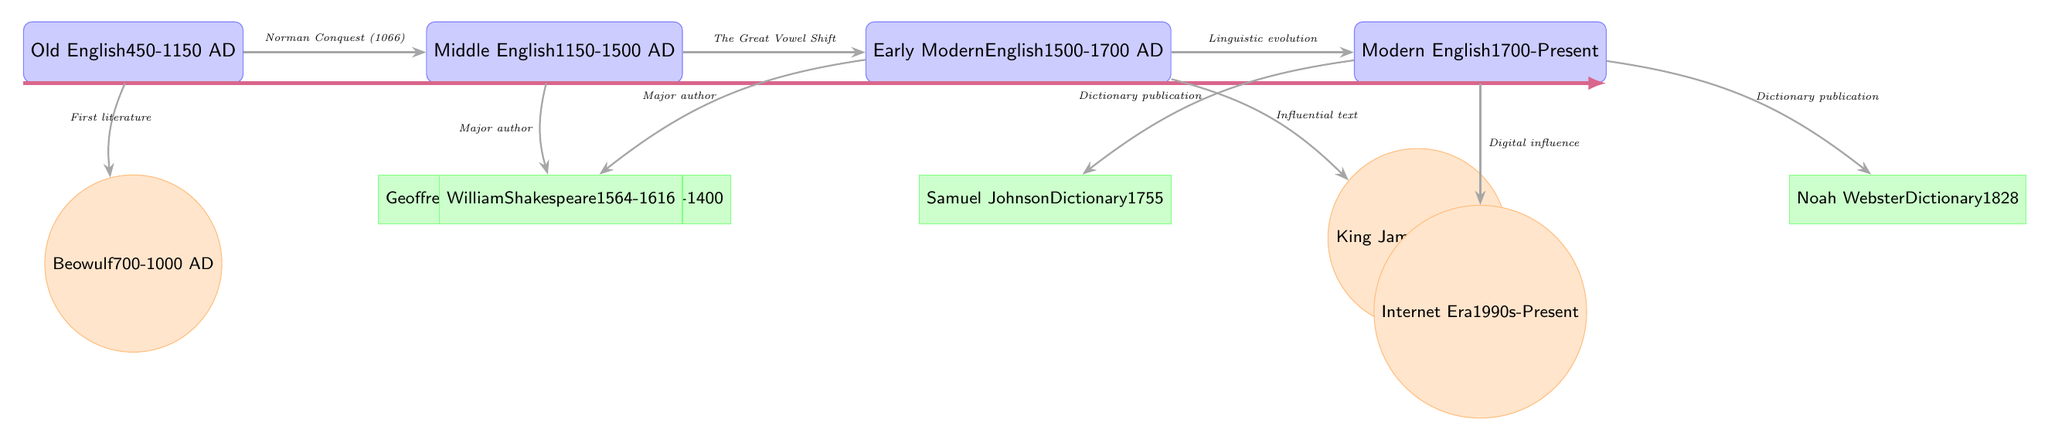What is the time period for Old English? The node labeled "Old English" states that it spans from 450 to 1150 AD. Therefore, this period can be identified directly from the diagram.
Answer: 450-1150 AD Who is the major author associated with Middle English? The diagram shows the author Geoffrey Chaucer under Middle English, and he is connected to the Canterbury Tales. This directly indicates his significance during this period.
Answer: Geoffrey Chaucer What major event led to the transition from Old English to Middle English? The diagram connects the Old English era to Middle English via the Norman Conquest (1066), marking a significant change between these periods.
Answer: Norman Conquest (1066) Which influential text was published during the Early Modern English period? Looking at the Early Modern English section, it is indicated that the King James Bible was published in 1611, making it an influential text of that time.
Answer: King James Bible How many major authors are listed in the Modern English section? The Modern English section contains two major authors, Samuel Johnson and Noah Webster, as indicated by the respective author nodes in that part of the diagram.
Answer: 2 What linguistic shift is noted between Middle English and Early Modern English? The diagram points out the Great Vowel Shift as a major linguistic change that occurred during the transition from Middle English to Early Modern English.
Answer: The Great Vowel Shift Which era follows Early Modern English in the timeline? The timeline shows that after Early Modern English, the next indicated era is Modern English, as perceived from the sequential arrangement of the nodes.
Answer: Modern English What is the last event listed in the diagram? The diagram illustrates the Internet Era as the final event listed under Modern English, marking a contemporary influence on the language.
Answer: Internet Era What publication year is associated with Samuel Johnson's dictionary? The diagram directly states that Samuel Johnson published his dictionary in 1755, providing a clear association with that year.
Answer: 1755 